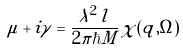<formula> <loc_0><loc_0><loc_500><loc_500>\mu + i \gamma = \frac { \lambda ^ { 2 } \, l } { 2 \pi \hbar { M } } \, \chi ( { q } , \Omega )</formula> 